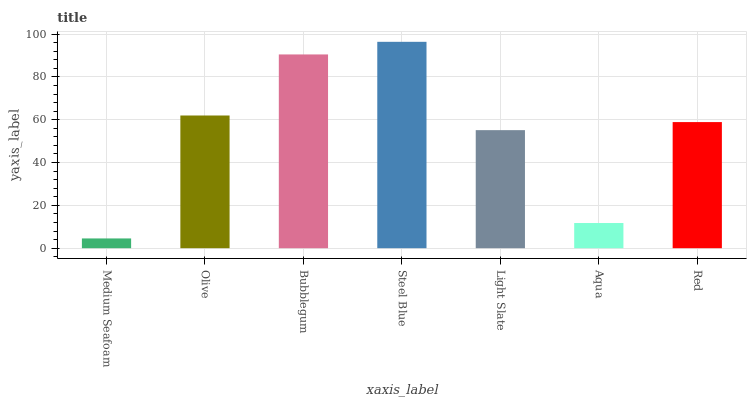Is Medium Seafoam the minimum?
Answer yes or no. Yes. Is Steel Blue the maximum?
Answer yes or no. Yes. Is Olive the minimum?
Answer yes or no. No. Is Olive the maximum?
Answer yes or no. No. Is Olive greater than Medium Seafoam?
Answer yes or no. Yes. Is Medium Seafoam less than Olive?
Answer yes or no. Yes. Is Medium Seafoam greater than Olive?
Answer yes or no. No. Is Olive less than Medium Seafoam?
Answer yes or no. No. Is Red the high median?
Answer yes or no. Yes. Is Red the low median?
Answer yes or no. Yes. Is Steel Blue the high median?
Answer yes or no. No. Is Steel Blue the low median?
Answer yes or no. No. 